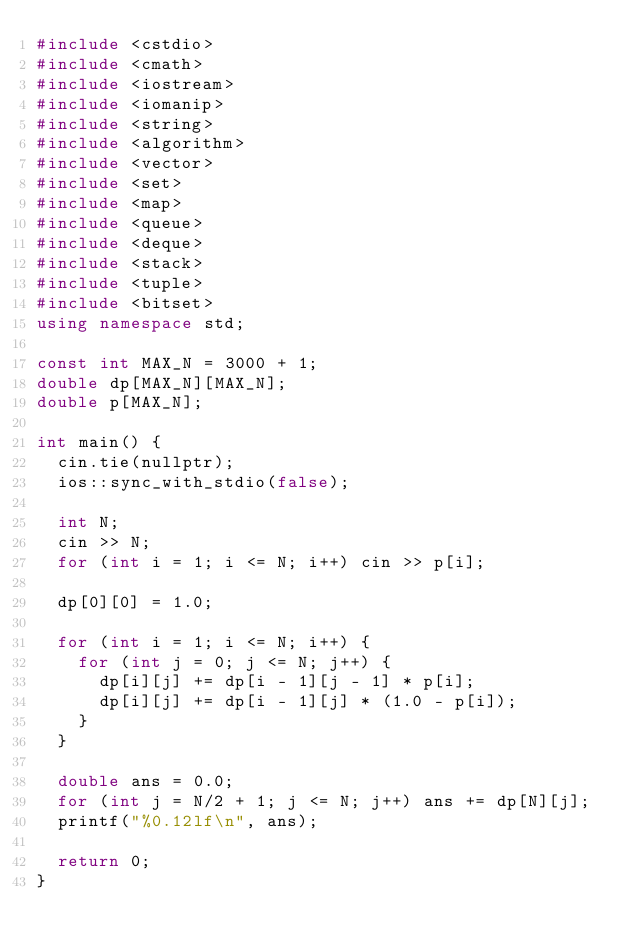<code> <loc_0><loc_0><loc_500><loc_500><_C++_>#include <cstdio>
#include <cmath>
#include <iostream>
#include <iomanip>
#include <string>
#include <algorithm>
#include <vector>
#include <set>
#include <map>
#include <queue>
#include <deque>
#include <stack>
#include <tuple>
#include <bitset>
using namespace std;

const int MAX_N = 3000 + 1;
double dp[MAX_N][MAX_N];
double p[MAX_N];

int main() {
  cin.tie(nullptr);
  ios::sync_with_stdio(false);

  int N;
  cin >> N;
  for (int i = 1; i <= N; i++) cin >> p[i];

  dp[0][0] = 1.0;
  
  for (int i = 1; i <= N; i++) {
    for (int j = 0; j <= N; j++) {
      dp[i][j] += dp[i - 1][j - 1] * p[i];
      dp[i][j] += dp[i - 1][j] * (1.0 - p[i]);
    }
  }

  double ans = 0.0;
  for (int j = N/2 + 1; j <= N; j++) ans += dp[N][j];
  printf("%0.12lf\n", ans);
  
  return 0;
}





</code> 